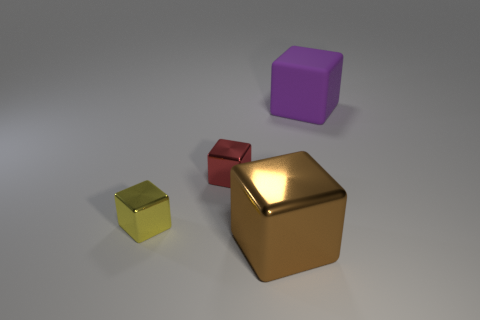Are the tiny yellow cube and the brown object made of the same material?
Your answer should be compact. Yes. What number of other things are there of the same material as the large purple cube
Offer a very short reply. 0. How many cubes are to the right of the yellow cube and to the left of the purple thing?
Ensure brevity in your answer.  2. The big metal cube has what color?
Your answer should be compact. Brown. There is a large purple thing that is the same shape as the small yellow metal object; what is it made of?
Ensure brevity in your answer.  Rubber. Are there any other things that are the same material as the tiny red cube?
Make the answer very short. Yes. Is the large matte thing the same color as the large metallic thing?
Keep it short and to the point. No. There is a big thing on the left side of the large object that is behind the large brown metal block; what shape is it?
Make the answer very short. Cube. What shape is the yellow thing that is made of the same material as the large brown object?
Offer a very short reply. Cube. There is a object in front of the yellow thing; does it have the same size as the big purple block?
Give a very brief answer. Yes. 